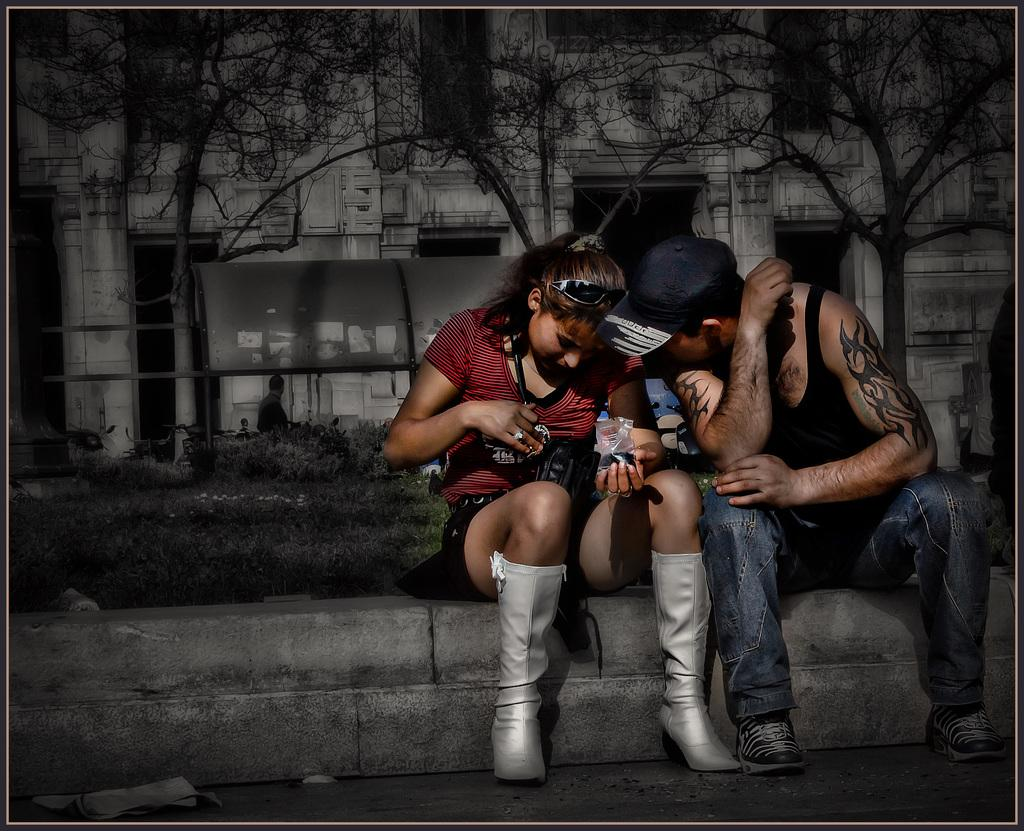How many people are in the image? There are two people in the image, a man and a woman. What are the man and woman doing in the image? The man and woman are sitting. What can be seen in the background of the image? There are plants, a man, buildings, and trees in the backdrop of the image. What is the woman holding in her hand? The woman is holding an object in her hand. What type of peace is being promoted by the knowledgeable man in the backdrop of the image? There is no man promoting peace or knowledge in the backdrop of the image; it only features plants, buildings, and trees. 